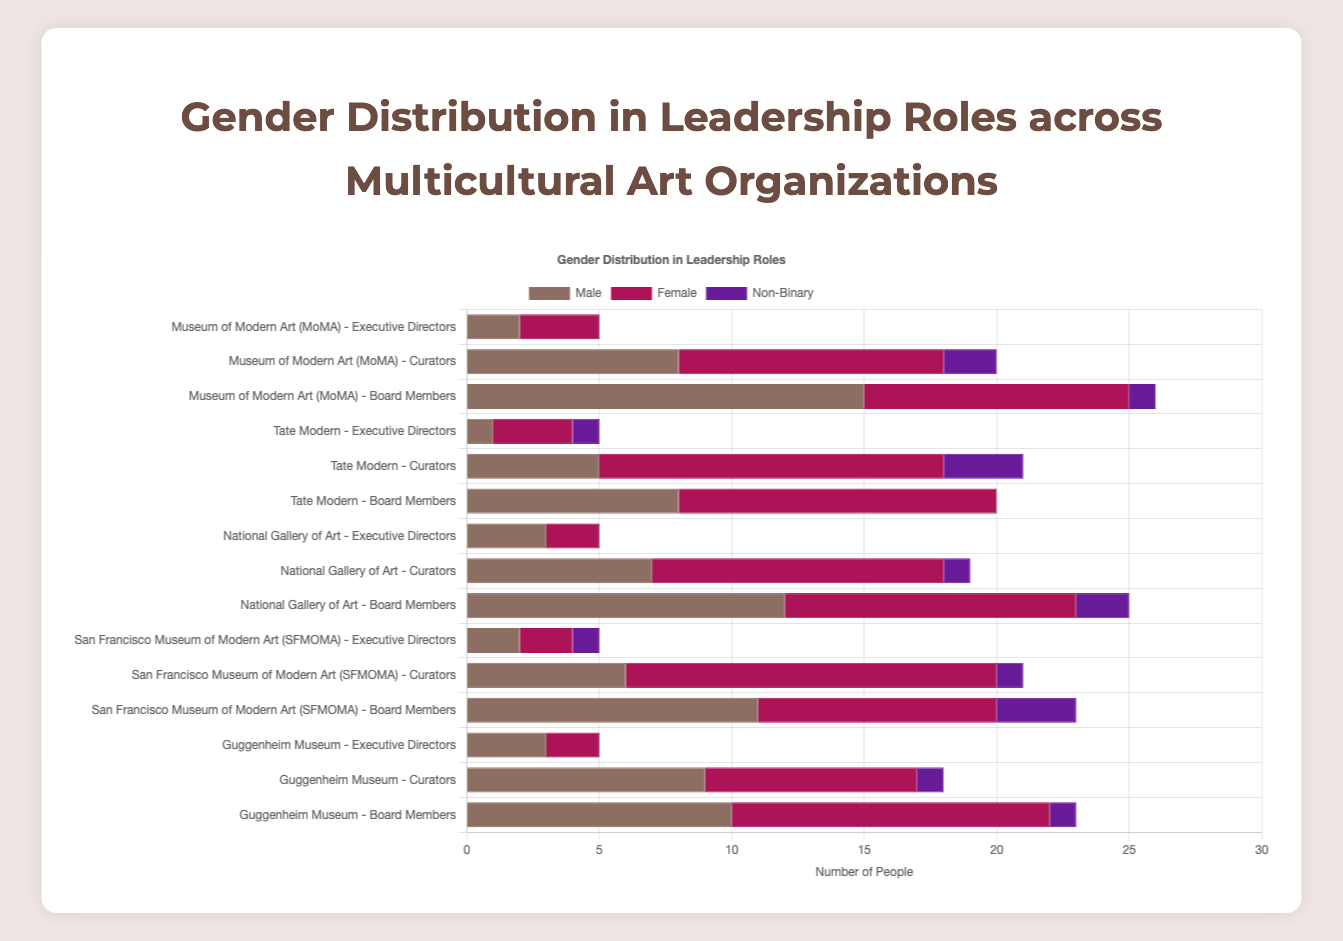Which organization has the highest number of female curators? The data shows the female curators per organization. Comparing the numbers: MoMA (10), Tate Modern (13), National Gallery of Art (11), SFMOMA (14), Guggenheim Museum (8), SFMOMA has the highest number with 14 female curators.
Answer: SFMOMA Which organization has the least number of male board members? The data shows the male board members per organization. Comparing the numbers: MoMA (15), Tate Modern (8), National Gallery of Art (12), SFMOMA (11), Guggenheim Museum (10). Tate Modern has the least number with 8 male board members.
Answer: Tate Modern What is the total number of non-binary individuals in leadership roles at the Guggenheim Museum? The data shows: Executive Directors (0), Curators (1), and Board Members (1). The total is 0+1+1 = 2.
Answer: 2 How does the number of female executive directors compare between MoMA and the National Gallery of Art? MoMA has 3 female executive directors and the National Gallery of Art has 2. Therefore, MoMA has 1 more female executive director than the National Gallery of Art.
Answer: MoMA has 1 more What is the combined total number of male curators at MoMA and Tate Modern? MoMA has 8 male curators and Tate Modern has 5. The combined total is 8 + 5 = 13.
Answer: 13 Which organization has the most balanced gender distribution among executive directors? Looking at the data, checking the differences between male and female/non-binary executive directors:
MoMA (2 male, 3 female, 0 non-binary): difference is 1
Tate Modern (1 male, 3 female, 1 non-binary): difference is 2
National Gallery of Art (3 male, 2 female, 0 non-binary): difference is 1
SFMOMA (2 male, 2 female, 1 non-binary): difference is 0
Guggenheim (3 male, 2 female, 0 non-binary): difference is 1
SFMOMA has the most balanced gender distribution with equal numbers of male and female executive directors.
Answer: SFMOMA Which organization has the highest number of non-binary curators compared to the other organizations? The data shows non-binary curators as follows: MoMA (2), Tate Modern (3), National Gallery of Art (1), SFMOMA (1), Guggenheim Museum (1). Tate Modern has the highest number with 3 non-binary curators.
Answer: Tate Modern What is the sum of female board members at all organizations? Calculating the sums for female board members: MoMA (10), Tate Modern (12), National Gallery of Art (11), SFMOMA (9), Guggenheim Museum (12). The total is 10 + 12 + 11 + 9 + 12 = 54.
Answer: 54 How do the total number of female and non-binary curators compare at the National Gallery of Art? National Gallery of Art has 11 female curators and 1 non-binary curator.
Answer: 11 females, 1 non-binary What is the difference between the number of male curators and female curators across all organizations? Summing up the totals for male and female curators: Male (MoMA: 8, Tate Modern: 5, National Gallery of Art: 7, SFMOMA: 6, Guggenheim Museum: 9) = 35; Female (MoMA: 10, Tate Modern: 13, National Gallery of Art: 11, SFMOMA: 14, Guggenheim Museum: 8) = 56. The difference is 56 - 35 = 21.
Answer: 21 